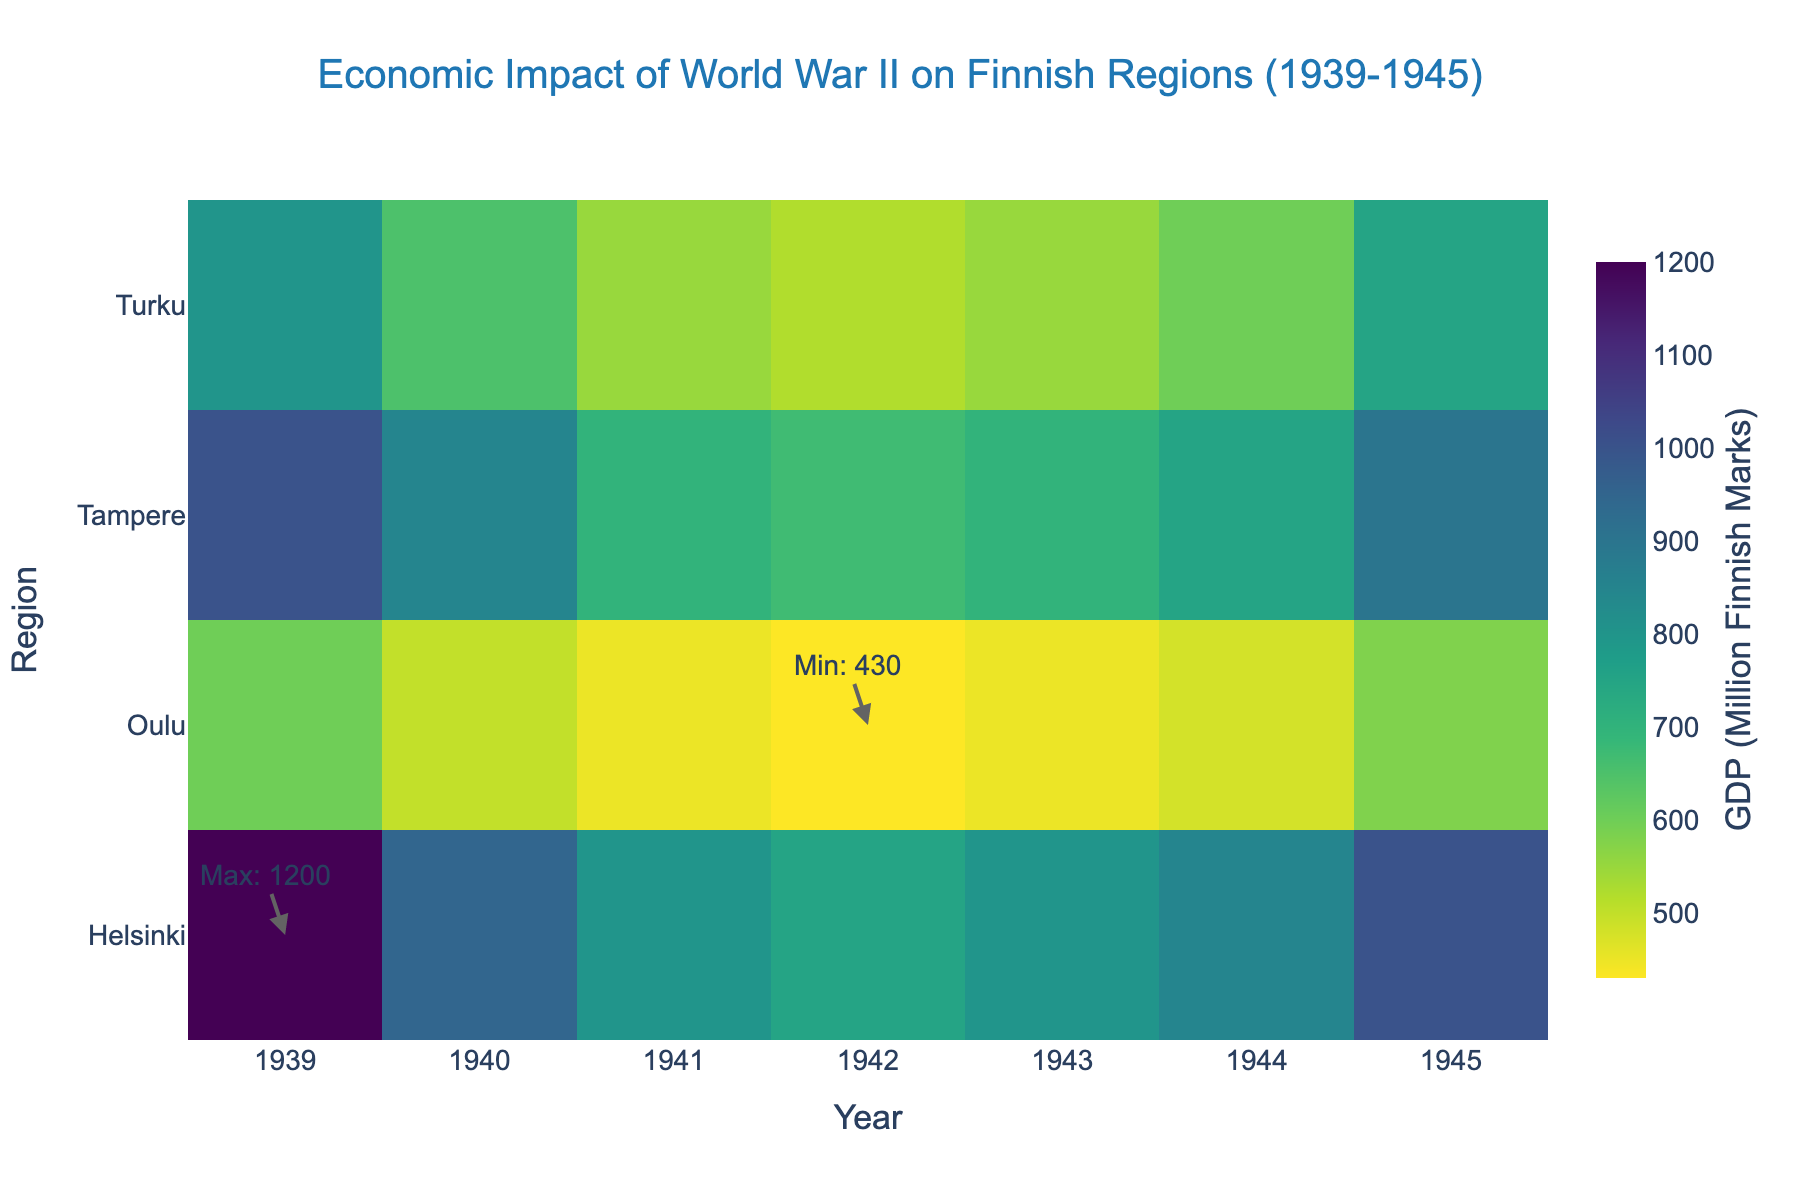What's the title of the heatmap? The title is written at the top center of the heatmap. It reads 'Economic Impact of World War II on Finnish Regions (1939-1945)'.
Answer: Economic Impact of World War II on Finnish Regions (1939-1945) Which region had the highest GDP during the period? To find the highest GDP, look for the annotation that indicates the maximum GDP value. It is marked on the heatmap. The region with the highest GDP is shown in the annotation.
Answer: Helsinki In which year did Turku have the lowest GDP? Trace the row corresponding to Turku and identify the year with the lowest value by checking the color intensity and hovering over the cells if needed. Turku's lowest GDP was in 1942.
Answer: 1942 How did the GDP in Oulu change from 1939 to 1945? Observe the values along the Oulu row from 1939 to 1945. Note the progression of colors and values. GDP in Oulu decreased from 600 million in 1939 to 580 million in 1945.
Answer: Decreased Between which years did Helsinki experience the greatest drop in GDP? Compare the year-on-year values for Helsinki to identify the period with the largest decrease. The largest drop is from 1939 (1200 million) to 1940 (950 million), a decrease of 250 million.
Answer: 1939-1940 Which region showed the most significant recovery in GDP from 1944 to 1945? Compare the GDP values for each region between 1944 and 1945. The region with the largest increase in color intensity and value represents the most significant recovery. It was Helsinki, with an increase from 850 million to 1000 million.
Answer: Helsinki What was the GDP in Tampere in 1941? Locate the intersection of the Tampere row and the 1941 column. The heatmap value indicates the GDP. It was 700 million Finnish Marks.
Answer: 700 million Finnish Marks How does the employment rate correlate with GDP during the war years for Helsinki? Although not directly visible, if analyzed, generally higher GDP values are associated with higher employment rates. Specifically, low GDP in wartime correlates with lower employment rates (e.g., 1941-1943). The detailed exploration requires matching these values from provided data but generally follows this trend.
Answer: Higher GDP correlates with higher employment Which region had the most stable GDP throughout the war years? Identify the region whose GDP values across the years show the least fluctuation. From the colors and values, it appears Oulu maintained relatively stable values, fluctuating minimally around 450-600 million marks.
Answer: Oulu 